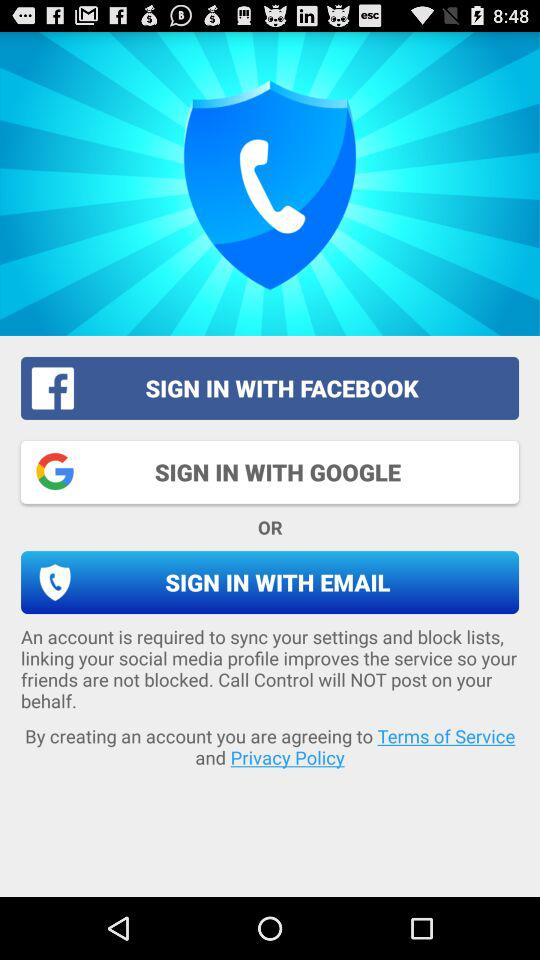What are the different sign in options? The different sign in options are "FACEBOOK", "GOOGLE" and "EMAIL". 